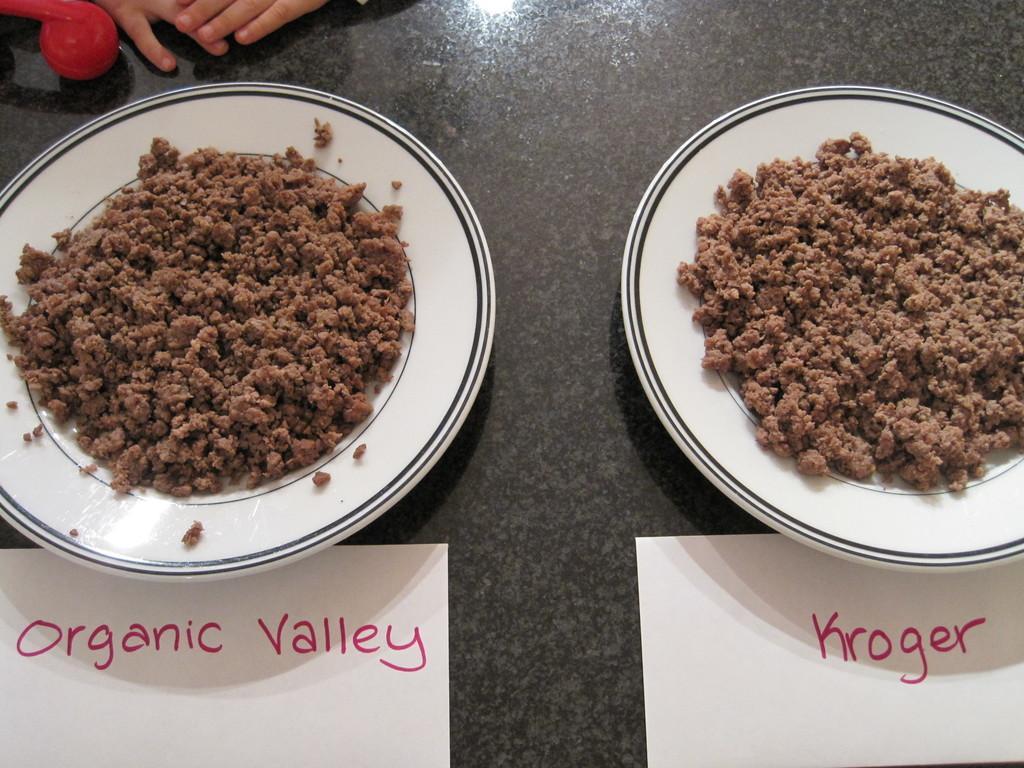Describe this image in one or two sentences. In the image we can see human fingers and there are two plates and food on the plate. Here we can see white papers on it there is a text and black surface. 